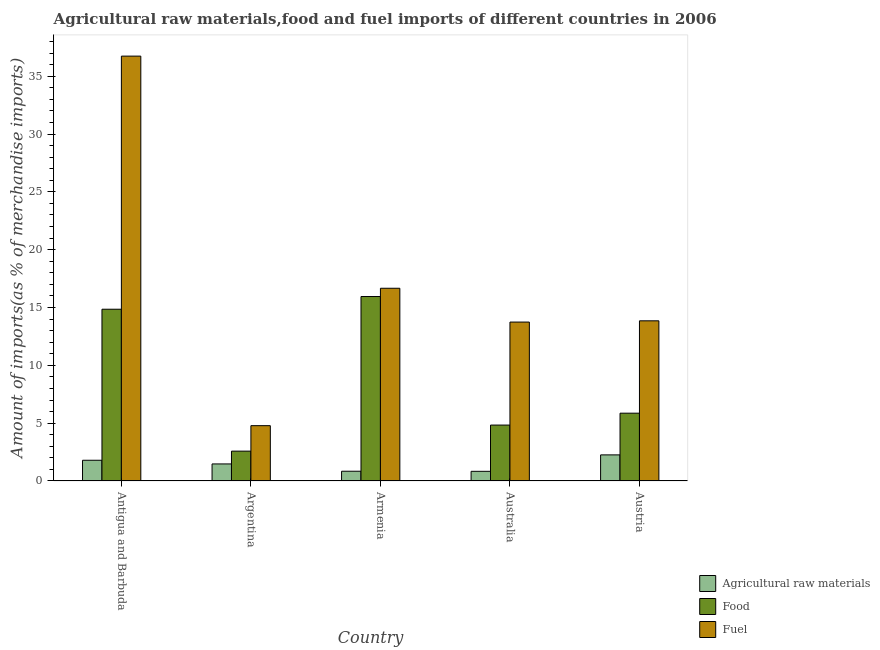How many different coloured bars are there?
Your answer should be very brief. 3. How many groups of bars are there?
Your response must be concise. 5. Are the number of bars per tick equal to the number of legend labels?
Your response must be concise. Yes. How many bars are there on the 1st tick from the left?
Offer a terse response. 3. How many bars are there on the 5th tick from the right?
Your answer should be compact. 3. What is the label of the 1st group of bars from the left?
Your response must be concise. Antigua and Barbuda. What is the percentage of fuel imports in Australia?
Your answer should be compact. 13.74. Across all countries, what is the maximum percentage of raw materials imports?
Ensure brevity in your answer.  2.26. Across all countries, what is the minimum percentage of raw materials imports?
Provide a succinct answer. 0.84. In which country was the percentage of food imports maximum?
Provide a short and direct response. Armenia. In which country was the percentage of raw materials imports minimum?
Ensure brevity in your answer.  Australia. What is the total percentage of food imports in the graph?
Make the answer very short. 44.08. What is the difference between the percentage of raw materials imports in Antigua and Barbuda and that in Austria?
Make the answer very short. -0.47. What is the difference between the percentage of food imports in Australia and the percentage of fuel imports in Argentina?
Your response must be concise. 0.05. What is the average percentage of raw materials imports per country?
Give a very brief answer. 1.44. What is the difference between the percentage of fuel imports and percentage of food imports in Armenia?
Offer a very short reply. 0.71. In how many countries, is the percentage of food imports greater than 12 %?
Make the answer very short. 2. What is the ratio of the percentage of fuel imports in Armenia to that in Australia?
Offer a very short reply. 1.21. What is the difference between the highest and the second highest percentage of raw materials imports?
Provide a short and direct response. 0.47. What is the difference between the highest and the lowest percentage of food imports?
Offer a terse response. 13.37. What does the 1st bar from the left in Argentina represents?
Offer a very short reply. Agricultural raw materials. What does the 1st bar from the right in Australia represents?
Provide a short and direct response. Fuel. How many bars are there?
Offer a terse response. 15. Are all the bars in the graph horizontal?
Provide a short and direct response. No. How many countries are there in the graph?
Your answer should be very brief. 5. What is the difference between two consecutive major ticks on the Y-axis?
Offer a terse response. 5. Are the values on the major ticks of Y-axis written in scientific E-notation?
Make the answer very short. No. Does the graph contain grids?
Provide a short and direct response. No. How many legend labels are there?
Provide a succinct answer. 3. What is the title of the graph?
Give a very brief answer. Agricultural raw materials,food and fuel imports of different countries in 2006. Does "Negligence towards kids" appear as one of the legend labels in the graph?
Offer a very short reply. No. What is the label or title of the Y-axis?
Your answer should be very brief. Amount of imports(as % of merchandise imports). What is the Amount of imports(as % of merchandise imports) of Agricultural raw materials in Antigua and Barbuda?
Your answer should be very brief. 1.79. What is the Amount of imports(as % of merchandise imports) of Food in Antigua and Barbuda?
Provide a short and direct response. 14.85. What is the Amount of imports(as % of merchandise imports) of Fuel in Antigua and Barbuda?
Your answer should be compact. 36.73. What is the Amount of imports(as % of merchandise imports) of Agricultural raw materials in Argentina?
Ensure brevity in your answer.  1.48. What is the Amount of imports(as % of merchandise imports) of Food in Argentina?
Provide a short and direct response. 2.58. What is the Amount of imports(as % of merchandise imports) of Fuel in Argentina?
Provide a short and direct response. 4.78. What is the Amount of imports(as % of merchandise imports) of Agricultural raw materials in Armenia?
Provide a succinct answer. 0.84. What is the Amount of imports(as % of merchandise imports) in Food in Armenia?
Your answer should be compact. 15.95. What is the Amount of imports(as % of merchandise imports) of Fuel in Armenia?
Offer a very short reply. 16.66. What is the Amount of imports(as % of merchandise imports) in Agricultural raw materials in Australia?
Give a very brief answer. 0.84. What is the Amount of imports(as % of merchandise imports) of Food in Australia?
Offer a terse response. 4.83. What is the Amount of imports(as % of merchandise imports) in Fuel in Australia?
Provide a short and direct response. 13.74. What is the Amount of imports(as % of merchandise imports) of Agricultural raw materials in Austria?
Provide a succinct answer. 2.26. What is the Amount of imports(as % of merchandise imports) of Food in Austria?
Your answer should be compact. 5.86. What is the Amount of imports(as % of merchandise imports) of Fuel in Austria?
Provide a short and direct response. 13.85. Across all countries, what is the maximum Amount of imports(as % of merchandise imports) of Agricultural raw materials?
Offer a terse response. 2.26. Across all countries, what is the maximum Amount of imports(as % of merchandise imports) in Food?
Your answer should be compact. 15.95. Across all countries, what is the maximum Amount of imports(as % of merchandise imports) of Fuel?
Your answer should be compact. 36.73. Across all countries, what is the minimum Amount of imports(as % of merchandise imports) of Agricultural raw materials?
Provide a succinct answer. 0.84. Across all countries, what is the minimum Amount of imports(as % of merchandise imports) in Food?
Give a very brief answer. 2.58. Across all countries, what is the minimum Amount of imports(as % of merchandise imports) of Fuel?
Your answer should be very brief. 4.78. What is the total Amount of imports(as % of merchandise imports) of Agricultural raw materials in the graph?
Provide a short and direct response. 7.21. What is the total Amount of imports(as % of merchandise imports) in Food in the graph?
Your response must be concise. 44.08. What is the total Amount of imports(as % of merchandise imports) in Fuel in the graph?
Keep it short and to the point. 85.77. What is the difference between the Amount of imports(as % of merchandise imports) of Agricultural raw materials in Antigua and Barbuda and that in Argentina?
Your answer should be compact. 0.32. What is the difference between the Amount of imports(as % of merchandise imports) of Food in Antigua and Barbuda and that in Argentina?
Provide a succinct answer. 12.27. What is the difference between the Amount of imports(as % of merchandise imports) in Fuel in Antigua and Barbuda and that in Argentina?
Make the answer very short. 31.95. What is the difference between the Amount of imports(as % of merchandise imports) of Agricultural raw materials in Antigua and Barbuda and that in Armenia?
Offer a very short reply. 0.95. What is the difference between the Amount of imports(as % of merchandise imports) of Food in Antigua and Barbuda and that in Armenia?
Provide a succinct answer. -1.1. What is the difference between the Amount of imports(as % of merchandise imports) in Fuel in Antigua and Barbuda and that in Armenia?
Offer a very short reply. 20.07. What is the difference between the Amount of imports(as % of merchandise imports) in Agricultural raw materials in Antigua and Barbuda and that in Australia?
Your answer should be very brief. 0.96. What is the difference between the Amount of imports(as % of merchandise imports) of Food in Antigua and Barbuda and that in Australia?
Ensure brevity in your answer.  10.02. What is the difference between the Amount of imports(as % of merchandise imports) of Fuel in Antigua and Barbuda and that in Australia?
Provide a short and direct response. 22.99. What is the difference between the Amount of imports(as % of merchandise imports) of Agricultural raw materials in Antigua and Barbuda and that in Austria?
Make the answer very short. -0.47. What is the difference between the Amount of imports(as % of merchandise imports) of Food in Antigua and Barbuda and that in Austria?
Make the answer very short. 8.99. What is the difference between the Amount of imports(as % of merchandise imports) of Fuel in Antigua and Barbuda and that in Austria?
Offer a very short reply. 22.89. What is the difference between the Amount of imports(as % of merchandise imports) of Agricultural raw materials in Argentina and that in Armenia?
Offer a terse response. 0.63. What is the difference between the Amount of imports(as % of merchandise imports) in Food in Argentina and that in Armenia?
Keep it short and to the point. -13.37. What is the difference between the Amount of imports(as % of merchandise imports) in Fuel in Argentina and that in Armenia?
Offer a terse response. -11.88. What is the difference between the Amount of imports(as % of merchandise imports) of Agricultural raw materials in Argentina and that in Australia?
Provide a succinct answer. 0.64. What is the difference between the Amount of imports(as % of merchandise imports) in Food in Argentina and that in Australia?
Give a very brief answer. -2.25. What is the difference between the Amount of imports(as % of merchandise imports) in Fuel in Argentina and that in Australia?
Provide a short and direct response. -8.96. What is the difference between the Amount of imports(as % of merchandise imports) in Agricultural raw materials in Argentina and that in Austria?
Provide a short and direct response. -0.78. What is the difference between the Amount of imports(as % of merchandise imports) in Food in Argentina and that in Austria?
Keep it short and to the point. -3.28. What is the difference between the Amount of imports(as % of merchandise imports) in Fuel in Argentina and that in Austria?
Ensure brevity in your answer.  -9.06. What is the difference between the Amount of imports(as % of merchandise imports) of Agricultural raw materials in Armenia and that in Australia?
Ensure brevity in your answer.  0.01. What is the difference between the Amount of imports(as % of merchandise imports) of Food in Armenia and that in Australia?
Ensure brevity in your answer.  11.12. What is the difference between the Amount of imports(as % of merchandise imports) of Fuel in Armenia and that in Australia?
Ensure brevity in your answer.  2.92. What is the difference between the Amount of imports(as % of merchandise imports) of Agricultural raw materials in Armenia and that in Austria?
Offer a very short reply. -1.41. What is the difference between the Amount of imports(as % of merchandise imports) of Food in Armenia and that in Austria?
Your answer should be compact. 10.09. What is the difference between the Amount of imports(as % of merchandise imports) of Fuel in Armenia and that in Austria?
Your response must be concise. 2.82. What is the difference between the Amount of imports(as % of merchandise imports) in Agricultural raw materials in Australia and that in Austria?
Ensure brevity in your answer.  -1.42. What is the difference between the Amount of imports(as % of merchandise imports) in Food in Australia and that in Austria?
Offer a terse response. -1.03. What is the difference between the Amount of imports(as % of merchandise imports) of Fuel in Australia and that in Austria?
Make the answer very short. -0.11. What is the difference between the Amount of imports(as % of merchandise imports) of Agricultural raw materials in Antigua and Barbuda and the Amount of imports(as % of merchandise imports) of Food in Argentina?
Keep it short and to the point. -0.79. What is the difference between the Amount of imports(as % of merchandise imports) in Agricultural raw materials in Antigua and Barbuda and the Amount of imports(as % of merchandise imports) in Fuel in Argentina?
Keep it short and to the point. -2.99. What is the difference between the Amount of imports(as % of merchandise imports) in Food in Antigua and Barbuda and the Amount of imports(as % of merchandise imports) in Fuel in Argentina?
Your answer should be compact. 10.07. What is the difference between the Amount of imports(as % of merchandise imports) in Agricultural raw materials in Antigua and Barbuda and the Amount of imports(as % of merchandise imports) in Food in Armenia?
Give a very brief answer. -14.16. What is the difference between the Amount of imports(as % of merchandise imports) of Agricultural raw materials in Antigua and Barbuda and the Amount of imports(as % of merchandise imports) of Fuel in Armenia?
Provide a succinct answer. -14.87. What is the difference between the Amount of imports(as % of merchandise imports) of Food in Antigua and Barbuda and the Amount of imports(as % of merchandise imports) of Fuel in Armenia?
Provide a short and direct response. -1.81. What is the difference between the Amount of imports(as % of merchandise imports) of Agricultural raw materials in Antigua and Barbuda and the Amount of imports(as % of merchandise imports) of Food in Australia?
Ensure brevity in your answer.  -3.04. What is the difference between the Amount of imports(as % of merchandise imports) of Agricultural raw materials in Antigua and Barbuda and the Amount of imports(as % of merchandise imports) of Fuel in Australia?
Make the answer very short. -11.95. What is the difference between the Amount of imports(as % of merchandise imports) of Food in Antigua and Barbuda and the Amount of imports(as % of merchandise imports) of Fuel in Australia?
Make the answer very short. 1.11. What is the difference between the Amount of imports(as % of merchandise imports) of Agricultural raw materials in Antigua and Barbuda and the Amount of imports(as % of merchandise imports) of Food in Austria?
Offer a very short reply. -4.07. What is the difference between the Amount of imports(as % of merchandise imports) of Agricultural raw materials in Antigua and Barbuda and the Amount of imports(as % of merchandise imports) of Fuel in Austria?
Your response must be concise. -12.06. What is the difference between the Amount of imports(as % of merchandise imports) in Food in Antigua and Barbuda and the Amount of imports(as % of merchandise imports) in Fuel in Austria?
Make the answer very short. 1. What is the difference between the Amount of imports(as % of merchandise imports) of Agricultural raw materials in Argentina and the Amount of imports(as % of merchandise imports) of Food in Armenia?
Your answer should be compact. -14.47. What is the difference between the Amount of imports(as % of merchandise imports) of Agricultural raw materials in Argentina and the Amount of imports(as % of merchandise imports) of Fuel in Armenia?
Provide a succinct answer. -15.19. What is the difference between the Amount of imports(as % of merchandise imports) of Food in Argentina and the Amount of imports(as % of merchandise imports) of Fuel in Armenia?
Make the answer very short. -14.08. What is the difference between the Amount of imports(as % of merchandise imports) in Agricultural raw materials in Argentina and the Amount of imports(as % of merchandise imports) in Food in Australia?
Offer a terse response. -3.36. What is the difference between the Amount of imports(as % of merchandise imports) in Agricultural raw materials in Argentina and the Amount of imports(as % of merchandise imports) in Fuel in Australia?
Offer a very short reply. -12.26. What is the difference between the Amount of imports(as % of merchandise imports) in Food in Argentina and the Amount of imports(as % of merchandise imports) in Fuel in Australia?
Make the answer very short. -11.16. What is the difference between the Amount of imports(as % of merchandise imports) of Agricultural raw materials in Argentina and the Amount of imports(as % of merchandise imports) of Food in Austria?
Provide a succinct answer. -4.39. What is the difference between the Amount of imports(as % of merchandise imports) in Agricultural raw materials in Argentina and the Amount of imports(as % of merchandise imports) in Fuel in Austria?
Your response must be concise. -12.37. What is the difference between the Amount of imports(as % of merchandise imports) of Food in Argentina and the Amount of imports(as % of merchandise imports) of Fuel in Austria?
Your answer should be compact. -11.27. What is the difference between the Amount of imports(as % of merchandise imports) of Agricultural raw materials in Armenia and the Amount of imports(as % of merchandise imports) of Food in Australia?
Provide a succinct answer. -3.99. What is the difference between the Amount of imports(as % of merchandise imports) of Agricultural raw materials in Armenia and the Amount of imports(as % of merchandise imports) of Fuel in Australia?
Offer a terse response. -12.9. What is the difference between the Amount of imports(as % of merchandise imports) of Food in Armenia and the Amount of imports(as % of merchandise imports) of Fuel in Australia?
Your answer should be very brief. 2.21. What is the difference between the Amount of imports(as % of merchandise imports) in Agricultural raw materials in Armenia and the Amount of imports(as % of merchandise imports) in Food in Austria?
Provide a succinct answer. -5.02. What is the difference between the Amount of imports(as % of merchandise imports) of Agricultural raw materials in Armenia and the Amount of imports(as % of merchandise imports) of Fuel in Austria?
Your answer should be very brief. -13. What is the difference between the Amount of imports(as % of merchandise imports) of Food in Armenia and the Amount of imports(as % of merchandise imports) of Fuel in Austria?
Give a very brief answer. 2.1. What is the difference between the Amount of imports(as % of merchandise imports) in Agricultural raw materials in Australia and the Amount of imports(as % of merchandise imports) in Food in Austria?
Your response must be concise. -5.03. What is the difference between the Amount of imports(as % of merchandise imports) of Agricultural raw materials in Australia and the Amount of imports(as % of merchandise imports) of Fuel in Austria?
Offer a very short reply. -13.01. What is the difference between the Amount of imports(as % of merchandise imports) in Food in Australia and the Amount of imports(as % of merchandise imports) in Fuel in Austria?
Ensure brevity in your answer.  -9.01. What is the average Amount of imports(as % of merchandise imports) in Agricultural raw materials per country?
Offer a terse response. 1.44. What is the average Amount of imports(as % of merchandise imports) in Food per country?
Your answer should be compact. 8.82. What is the average Amount of imports(as % of merchandise imports) of Fuel per country?
Give a very brief answer. 17.15. What is the difference between the Amount of imports(as % of merchandise imports) in Agricultural raw materials and Amount of imports(as % of merchandise imports) in Food in Antigua and Barbuda?
Your answer should be compact. -13.06. What is the difference between the Amount of imports(as % of merchandise imports) in Agricultural raw materials and Amount of imports(as % of merchandise imports) in Fuel in Antigua and Barbuda?
Give a very brief answer. -34.94. What is the difference between the Amount of imports(as % of merchandise imports) in Food and Amount of imports(as % of merchandise imports) in Fuel in Antigua and Barbuda?
Keep it short and to the point. -21.88. What is the difference between the Amount of imports(as % of merchandise imports) in Agricultural raw materials and Amount of imports(as % of merchandise imports) in Food in Argentina?
Your answer should be compact. -1.11. What is the difference between the Amount of imports(as % of merchandise imports) of Agricultural raw materials and Amount of imports(as % of merchandise imports) of Fuel in Argentina?
Provide a succinct answer. -3.31. What is the difference between the Amount of imports(as % of merchandise imports) of Food and Amount of imports(as % of merchandise imports) of Fuel in Argentina?
Make the answer very short. -2.2. What is the difference between the Amount of imports(as % of merchandise imports) of Agricultural raw materials and Amount of imports(as % of merchandise imports) of Food in Armenia?
Offer a terse response. -15.11. What is the difference between the Amount of imports(as % of merchandise imports) in Agricultural raw materials and Amount of imports(as % of merchandise imports) in Fuel in Armenia?
Provide a short and direct response. -15.82. What is the difference between the Amount of imports(as % of merchandise imports) in Food and Amount of imports(as % of merchandise imports) in Fuel in Armenia?
Offer a very short reply. -0.71. What is the difference between the Amount of imports(as % of merchandise imports) of Agricultural raw materials and Amount of imports(as % of merchandise imports) of Food in Australia?
Your answer should be very brief. -4. What is the difference between the Amount of imports(as % of merchandise imports) of Agricultural raw materials and Amount of imports(as % of merchandise imports) of Fuel in Australia?
Ensure brevity in your answer.  -12.9. What is the difference between the Amount of imports(as % of merchandise imports) of Food and Amount of imports(as % of merchandise imports) of Fuel in Australia?
Ensure brevity in your answer.  -8.91. What is the difference between the Amount of imports(as % of merchandise imports) in Agricultural raw materials and Amount of imports(as % of merchandise imports) in Food in Austria?
Give a very brief answer. -3.61. What is the difference between the Amount of imports(as % of merchandise imports) in Agricultural raw materials and Amount of imports(as % of merchandise imports) in Fuel in Austria?
Provide a short and direct response. -11.59. What is the difference between the Amount of imports(as % of merchandise imports) in Food and Amount of imports(as % of merchandise imports) in Fuel in Austria?
Give a very brief answer. -7.99. What is the ratio of the Amount of imports(as % of merchandise imports) of Agricultural raw materials in Antigua and Barbuda to that in Argentina?
Provide a succinct answer. 1.21. What is the ratio of the Amount of imports(as % of merchandise imports) in Food in Antigua and Barbuda to that in Argentina?
Your answer should be very brief. 5.75. What is the ratio of the Amount of imports(as % of merchandise imports) of Fuel in Antigua and Barbuda to that in Argentina?
Your answer should be compact. 7.68. What is the ratio of the Amount of imports(as % of merchandise imports) in Agricultural raw materials in Antigua and Barbuda to that in Armenia?
Your answer should be compact. 2.12. What is the ratio of the Amount of imports(as % of merchandise imports) of Food in Antigua and Barbuda to that in Armenia?
Offer a very short reply. 0.93. What is the ratio of the Amount of imports(as % of merchandise imports) of Fuel in Antigua and Barbuda to that in Armenia?
Your response must be concise. 2.2. What is the ratio of the Amount of imports(as % of merchandise imports) in Agricultural raw materials in Antigua and Barbuda to that in Australia?
Your response must be concise. 2.14. What is the ratio of the Amount of imports(as % of merchandise imports) of Food in Antigua and Barbuda to that in Australia?
Your response must be concise. 3.07. What is the ratio of the Amount of imports(as % of merchandise imports) in Fuel in Antigua and Barbuda to that in Australia?
Offer a terse response. 2.67. What is the ratio of the Amount of imports(as % of merchandise imports) in Agricultural raw materials in Antigua and Barbuda to that in Austria?
Your answer should be compact. 0.79. What is the ratio of the Amount of imports(as % of merchandise imports) of Food in Antigua and Barbuda to that in Austria?
Keep it short and to the point. 2.53. What is the ratio of the Amount of imports(as % of merchandise imports) in Fuel in Antigua and Barbuda to that in Austria?
Your answer should be very brief. 2.65. What is the ratio of the Amount of imports(as % of merchandise imports) of Agricultural raw materials in Argentina to that in Armenia?
Make the answer very short. 1.75. What is the ratio of the Amount of imports(as % of merchandise imports) of Food in Argentina to that in Armenia?
Provide a short and direct response. 0.16. What is the ratio of the Amount of imports(as % of merchandise imports) in Fuel in Argentina to that in Armenia?
Provide a succinct answer. 0.29. What is the ratio of the Amount of imports(as % of merchandise imports) in Agricultural raw materials in Argentina to that in Australia?
Provide a short and direct response. 1.76. What is the ratio of the Amount of imports(as % of merchandise imports) in Food in Argentina to that in Australia?
Provide a short and direct response. 0.53. What is the ratio of the Amount of imports(as % of merchandise imports) of Fuel in Argentina to that in Australia?
Give a very brief answer. 0.35. What is the ratio of the Amount of imports(as % of merchandise imports) in Agricultural raw materials in Argentina to that in Austria?
Your response must be concise. 0.65. What is the ratio of the Amount of imports(as % of merchandise imports) of Food in Argentina to that in Austria?
Offer a terse response. 0.44. What is the ratio of the Amount of imports(as % of merchandise imports) of Fuel in Argentina to that in Austria?
Provide a succinct answer. 0.35. What is the ratio of the Amount of imports(as % of merchandise imports) in Food in Armenia to that in Australia?
Keep it short and to the point. 3.3. What is the ratio of the Amount of imports(as % of merchandise imports) of Fuel in Armenia to that in Australia?
Your answer should be compact. 1.21. What is the ratio of the Amount of imports(as % of merchandise imports) of Agricultural raw materials in Armenia to that in Austria?
Offer a very short reply. 0.37. What is the ratio of the Amount of imports(as % of merchandise imports) in Food in Armenia to that in Austria?
Your response must be concise. 2.72. What is the ratio of the Amount of imports(as % of merchandise imports) of Fuel in Armenia to that in Austria?
Offer a terse response. 1.2. What is the ratio of the Amount of imports(as % of merchandise imports) of Agricultural raw materials in Australia to that in Austria?
Offer a terse response. 0.37. What is the ratio of the Amount of imports(as % of merchandise imports) in Food in Australia to that in Austria?
Offer a very short reply. 0.82. What is the ratio of the Amount of imports(as % of merchandise imports) of Fuel in Australia to that in Austria?
Make the answer very short. 0.99. What is the difference between the highest and the second highest Amount of imports(as % of merchandise imports) in Agricultural raw materials?
Give a very brief answer. 0.47. What is the difference between the highest and the second highest Amount of imports(as % of merchandise imports) of Food?
Ensure brevity in your answer.  1.1. What is the difference between the highest and the second highest Amount of imports(as % of merchandise imports) of Fuel?
Offer a terse response. 20.07. What is the difference between the highest and the lowest Amount of imports(as % of merchandise imports) of Agricultural raw materials?
Provide a short and direct response. 1.42. What is the difference between the highest and the lowest Amount of imports(as % of merchandise imports) in Food?
Provide a succinct answer. 13.37. What is the difference between the highest and the lowest Amount of imports(as % of merchandise imports) in Fuel?
Your answer should be compact. 31.95. 